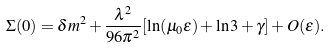<formula> <loc_0><loc_0><loc_500><loc_500>\Sigma ( 0 ) = \delta m ^ { 2 } + \frac { \lambda ^ { 2 } } { 9 6 \pi ^ { 2 } } [ \ln ( \mu _ { 0 } \epsilon ) + \ln 3 + \gamma ] + O ( \epsilon ) .</formula> 